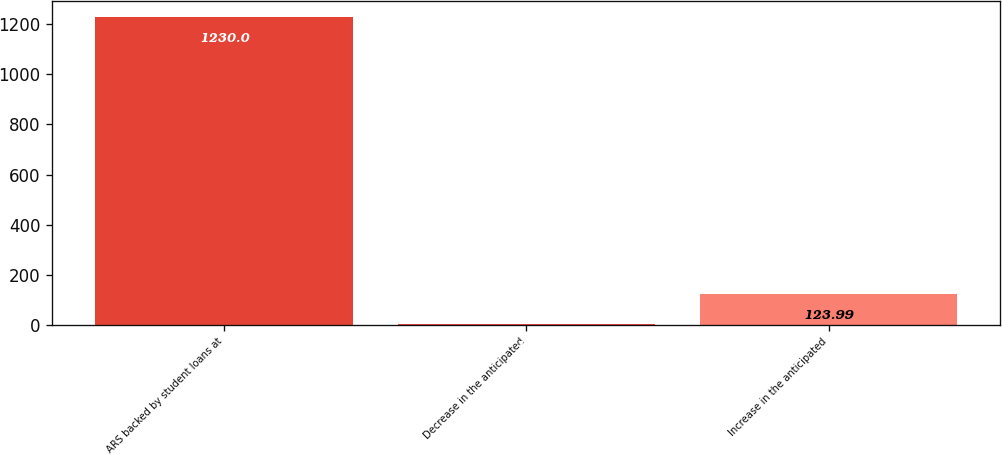Convert chart to OTSL. <chart><loc_0><loc_0><loc_500><loc_500><bar_chart><fcel>ARS backed by student loans at<fcel>Decrease in the anticipated<fcel>Increase in the anticipated<nl><fcel>1230<fcel>1.1<fcel>123.99<nl></chart> 